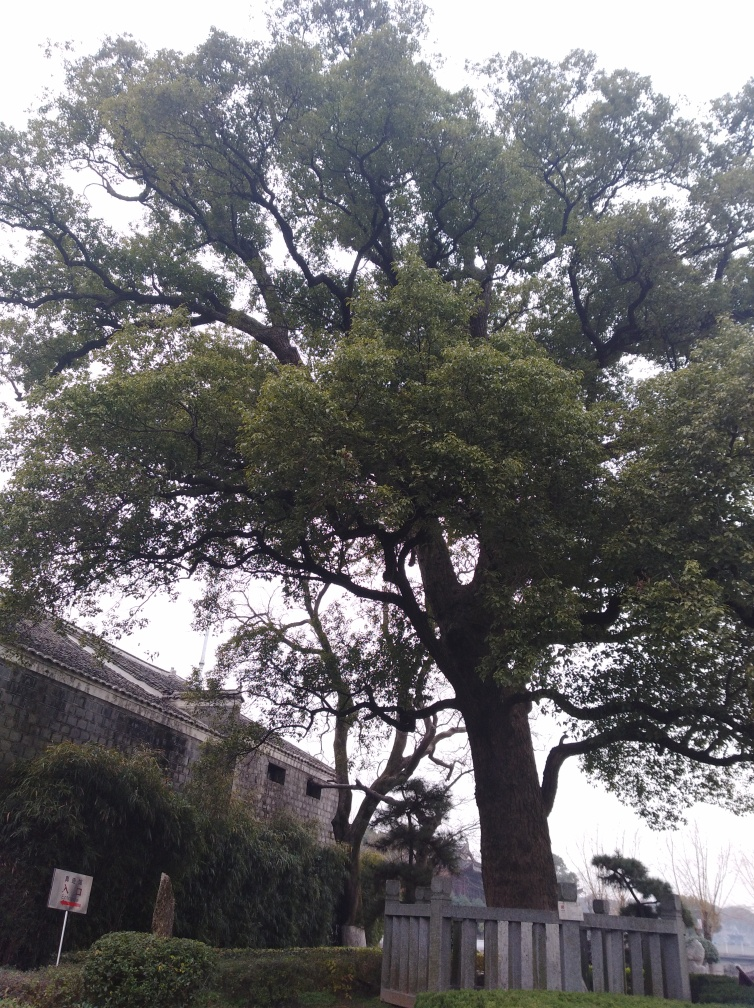Can you guess the season captured in this image? The lush green leaves on the tree suggest it might be late spring or summer. The absence of flowers or foliage with autumnal colors suggests it's not fall, and the greenery rules out winter as well. 